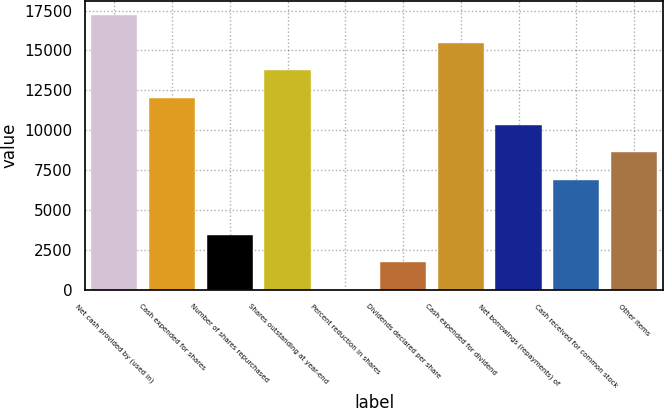Convert chart to OTSL. <chart><loc_0><loc_0><loc_500><loc_500><bar_chart><fcel>Net cash provided by (used in)<fcel>Cash expended for shares<fcel>Number of shares repurchased<fcel>Shares outstanding at year-end<fcel>Percent reduction in shares<fcel>Dividends declared per share<fcel>Cash expended for dividend<fcel>Net borrowings (repayments) of<fcel>Cash received for common stock<fcel>Other items<nl><fcel>17217<fcel>12052<fcel>3443.56<fcel>13773.6<fcel>0.2<fcel>1721.88<fcel>15495.3<fcel>10330.3<fcel>6886.92<fcel>8608.6<nl></chart> 